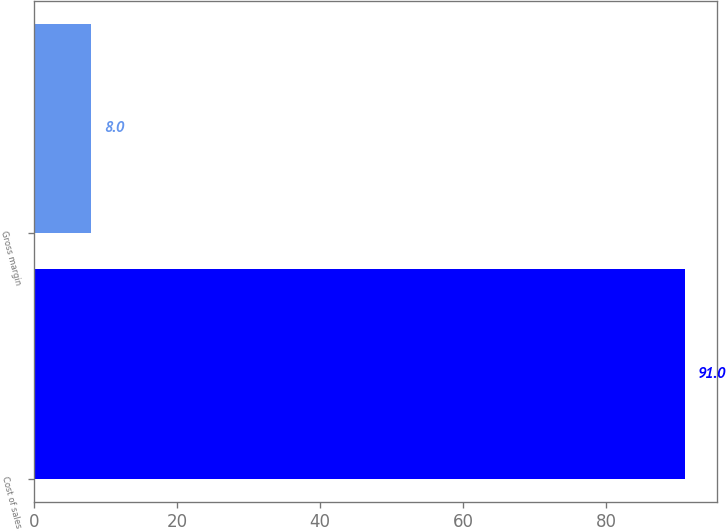Convert chart. <chart><loc_0><loc_0><loc_500><loc_500><bar_chart><fcel>Cost of sales<fcel>Gross margin<nl><fcel>91<fcel>8<nl></chart> 